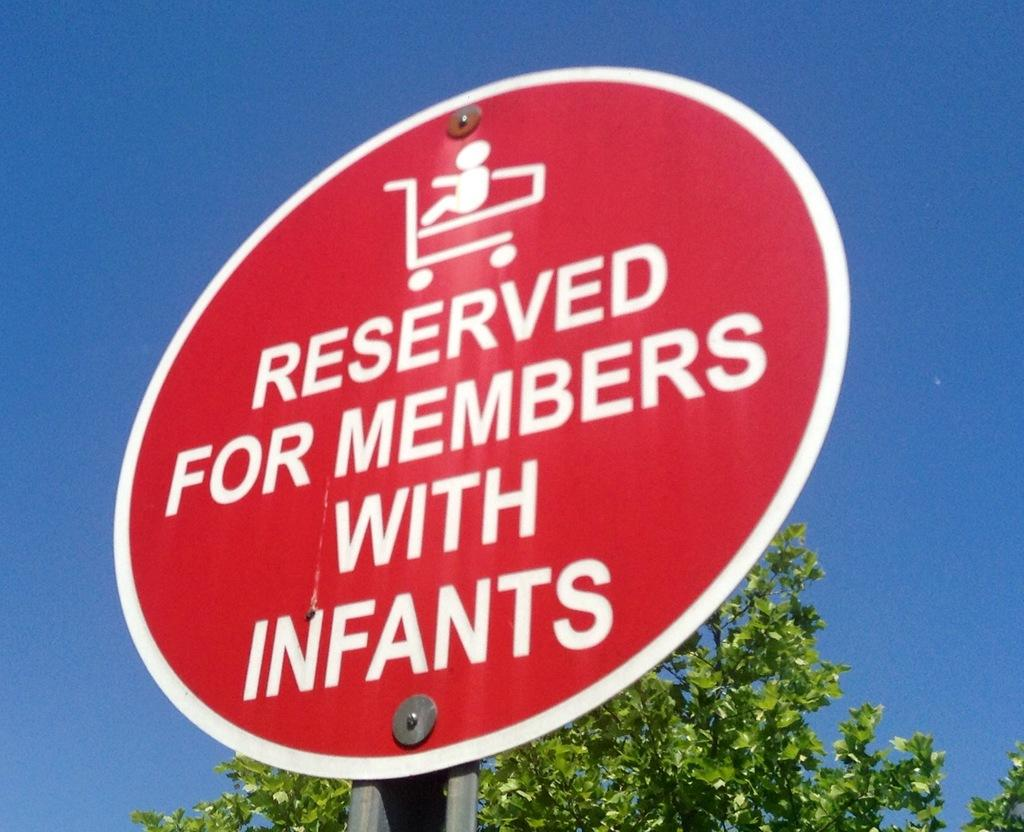<image>
Summarize the visual content of the image. A round red sign shows that the spot is saved for members with infants. 